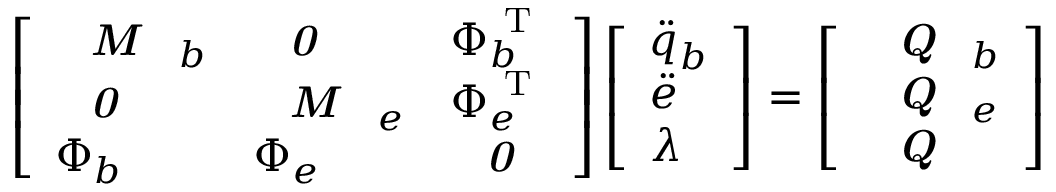Convert formula to latex. <formula><loc_0><loc_0><loc_500><loc_500>\left [ \begin{array} { l l l } { M _ { b } } & { 0 } & { \Phi _ { b } ^ { T } } \\ { 0 } & { M _ { e } } & { \Phi _ { e } ^ { T } } \\ { \Phi _ { b } } & { \Phi _ { e } } & { 0 } \end{array} \right ] \left [ \begin{array} { l } { \ddot { q } _ { b } } \\ { \ddot { e } } \\ { \lambda } \end{array} \right ] = \left [ \begin{array} { l } { Q _ { b } } \\ { Q _ { e } } \\ { Q } \end{array} \right ]</formula> 